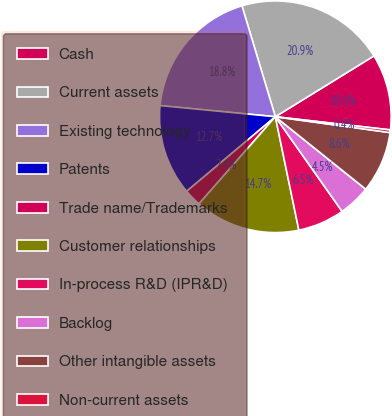<chart> <loc_0><loc_0><loc_500><loc_500><pie_chart><fcel>Cash<fcel>Current assets<fcel>Existing technology<fcel>Patents<fcel>Trade name/Trademarks<fcel>Customer relationships<fcel>In-process R&D (IPR&D)<fcel>Backlog<fcel>Other intangible assets<fcel>Non-current assets<nl><fcel>10.61%<fcel>20.86%<fcel>18.81%<fcel>12.66%<fcel>2.42%<fcel>14.71%<fcel>6.52%<fcel>4.47%<fcel>8.57%<fcel>0.37%<nl></chart> 